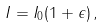<formula> <loc_0><loc_0><loc_500><loc_500>I = I _ { 0 } ( 1 + \epsilon ) \, ,</formula> 